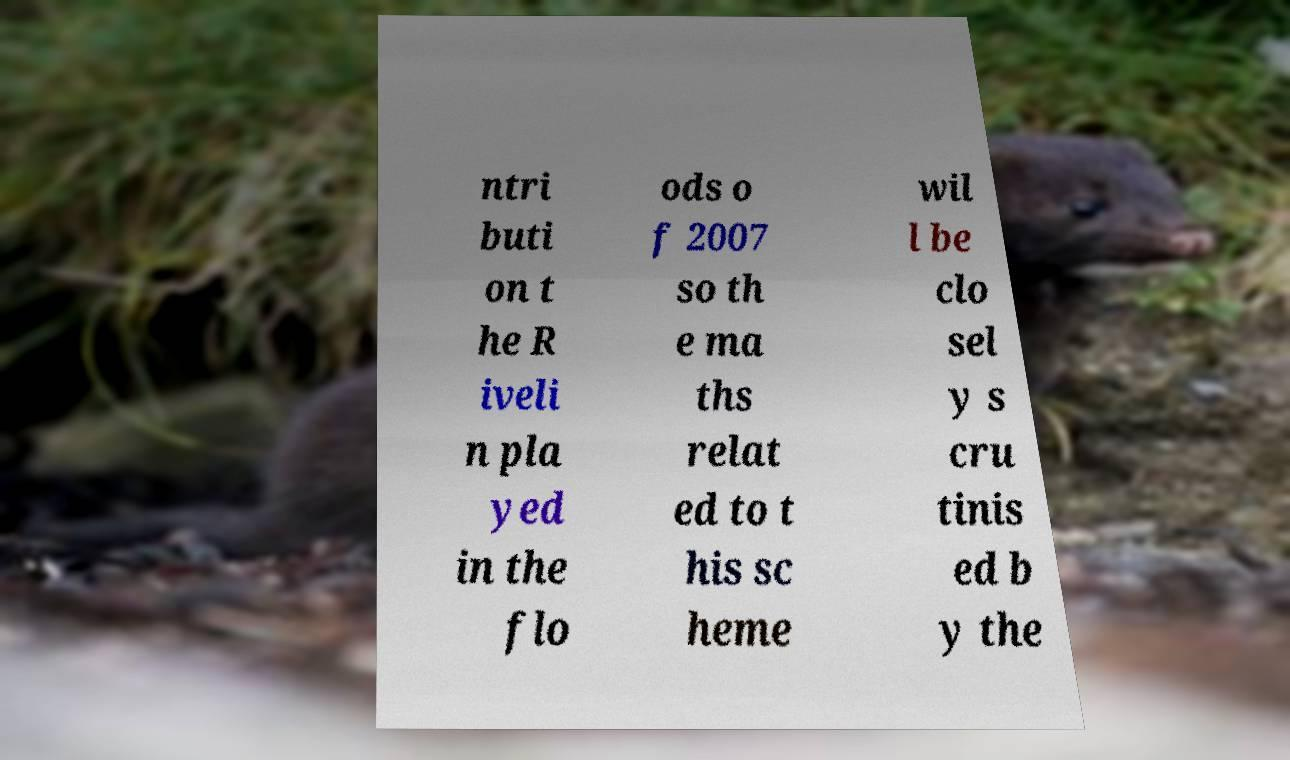I need the written content from this picture converted into text. Can you do that? ntri buti on t he R iveli n pla yed in the flo ods o f 2007 so th e ma ths relat ed to t his sc heme wil l be clo sel y s cru tinis ed b y the 